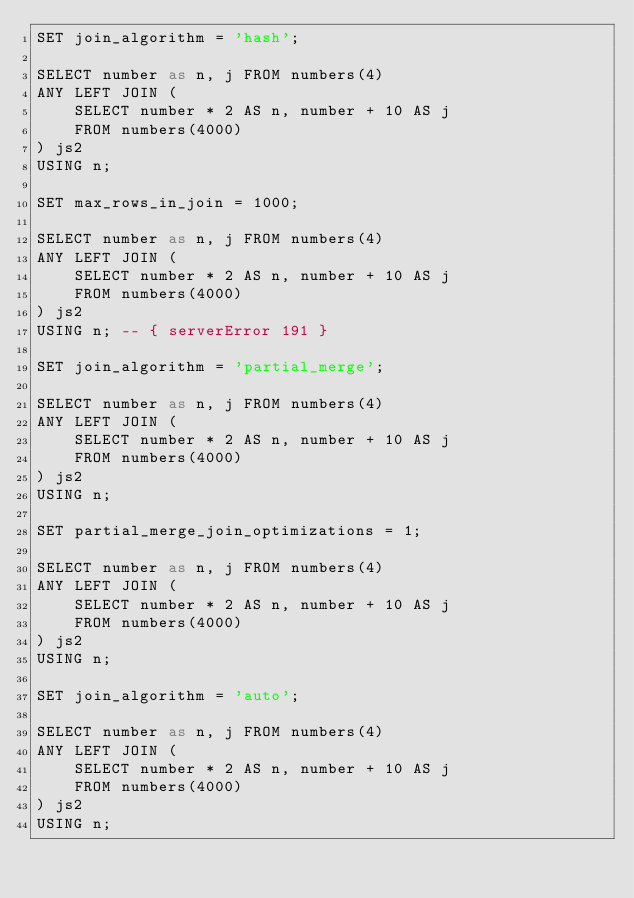Convert code to text. <code><loc_0><loc_0><loc_500><loc_500><_SQL_>SET join_algorithm = 'hash';

SELECT number as n, j FROM numbers(4)
ANY LEFT JOIN (
    SELECT number * 2 AS n, number + 10 AS j
    FROM numbers(4000)
) js2
USING n;

SET max_rows_in_join = 1000;

SELECT number as n, j FROM numbers(4)
ANY LEFT JOIN (
    SELECT number * 2 AS n, number + 10 AS j
    FROM numbers(4000)
) js2
USING n; -- { serverError 191 }

SET join_algorithm = 'partial_merge';

SELECT number as n, j FROM numbers(4)
ANY LEFT JOIN (
    SELECT number * 2 AS n, number + 10 AS j
    FROM numbers(4000)
) js2
USING n;

SET partial_merge_join_optimizations = 1;

SELECT number as n, j FROM numbers(4)
ANY LEFT JOIN (
    SELECT number * 2 AS n, number + 10 AS j
    FROM numbers(4000)
) js2
USING n;

SET join_algorithm = 'auto';

SELECT number as n, j FROM numbers(4)
ANY LEFT JOIN (
    SELECT number * 2 AS n, number + 10 AS j
    FROM numbers(4000)
) js2
USING n;
</code> 